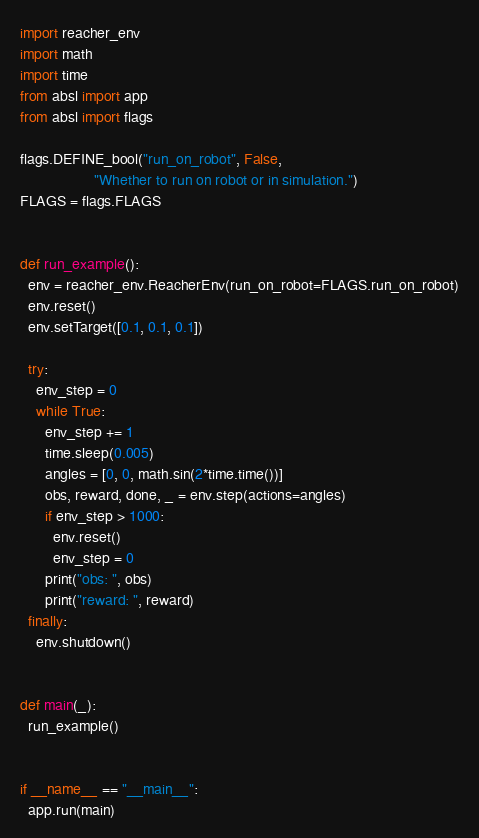Convert code to text. <code><loc_0><loc_0><loc_500><loc_500><_Python_>import reacher_env
import math
import time
from absl import app
from absl import flags

flags.DEFINE_bool("run_on_robot", False,
                  "Whether to run on robot or in simulation.")
FLAGS = flags.FLAGS


def run_example():
  env = reacher_env.ReacherEnv(run_on_robot=FLAGS.run_on_robot)
  env.reset()
  env.setTarget([0.1, 0.1, 0.1])

  try:
    env_step = 0
    while True:
      env_step += 1
      time.sleep(0.005)
      angles = [0, 0, math.sin(2*time.time())]
      obs, reward, done, _ = env.step(actions=angles)
      if env_step > 1000:
        env.reset()
        env_step = 0
      print("obs: ", obs)
      print("reward: ", reward)
  finally:
    env.shutdown()


def main(_):
  run_example()


if __name__ == "__main__":
  app.run(main)
</code> 